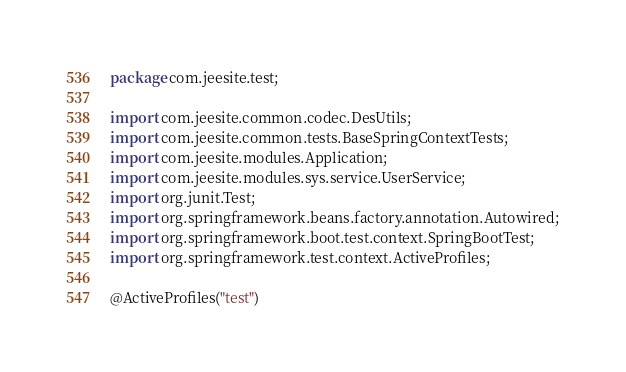<code> <loc_0><loc_0><loc_500><loc_500><_Java_>package com.jeesite.test;

import com.jeesite.common.codec.DesUtils;
import com.jeesite.common.tests.BaseSpringContextTests;
import com.jeesite.modules.Application;
import com.jeesite.modules.sys.service.UserService;
import org.junit.Test;
import org.springframework.beans.factory.annotation.Autowired;
import org.springframework.boot.test.context.SpringBootTest;
import org.springframework.test.context.ActiveProfiles;

@ActiveProfiles("test")</code> 